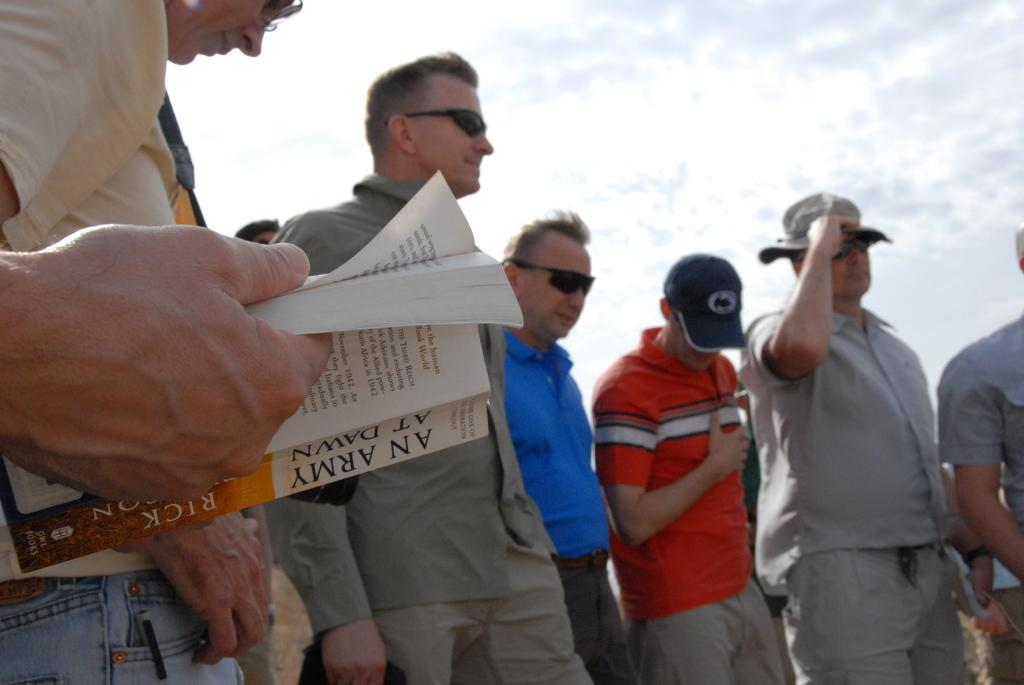What can be seen in the image involving multiple people? There is a group of men in the image. What object related to reading is present in the image? There is a book in the image. What type of headwear can be seen in the image? There are caps in the image. What protective eyewear is visible in the image? There are goggles in the image. What can be seen in the background of the image? The sky is visible in the background of the image. Can you tell me how many times the group of men laughs during the party in the image? There is no party depicted in the image, and therefore no laughter can be observed. What part of the brain is visible in the image? There is no brain present in the image. 